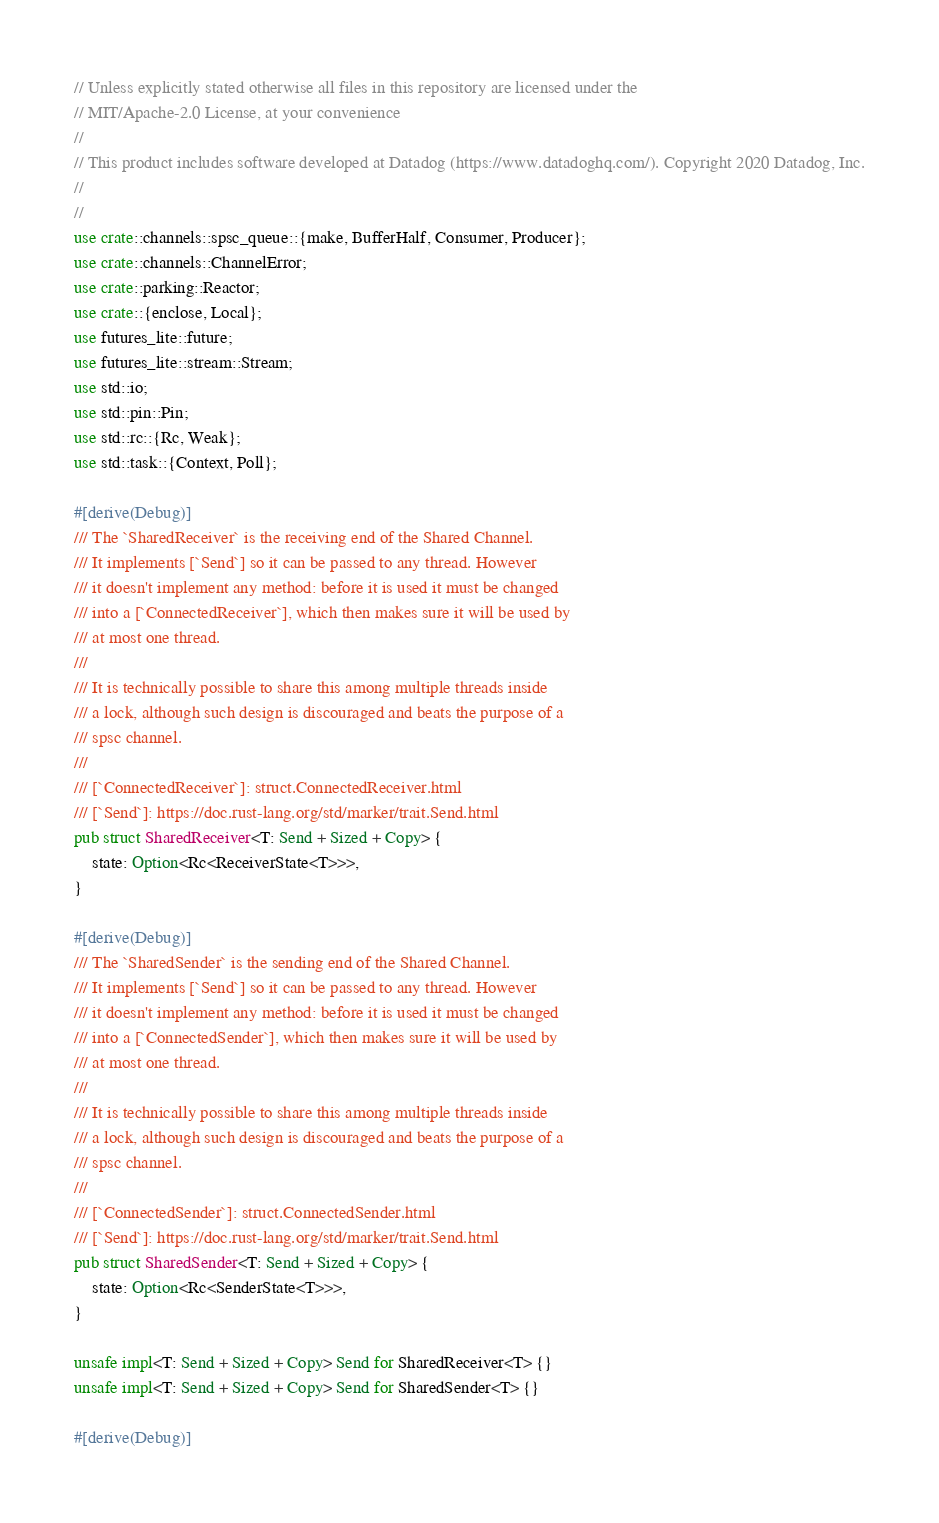<code> <loc_0><loc_0><loc_500><loc_500><_Rust_>// Unless explicitly stated otherwise all files in this repository are licensed under the
// MIT/Apache-2.0 License, at your convenience
//
// This product includes software developed at Datadog (https://www.datadoghq.com/). Copyright 2020 Datadog, Inc.
//
//
use crate::channels::spsc_queue::{make, BufferHalf, Consumer, Producer};
use crate::channels::ChannelError;
use crate::parking::Reactor;
use crate::{enclose, Local};
use futures_lite::future;
use futures_lite::stream::Stream;
use std::io;
use std::pin::Pin;
use std::rc::{Rc, Weak};
use std::task::{Context, Poll};

#[derive(Debug)]
/// The `SharedReceiver` is the receiving end of the Shared Channel.
/// It implements [`Send`] so it can be passed to any thread. However
/// it doesn't implement any method: before it is used it must be changed
/// into a [`ConnectedReceiver`], which then makes sure it will be used by
/// at most one thread.
///
/// It is technically possible to share this among multiple threads inside
/// a lock, although such design is discouraged and beats the purpose of a
/// spsc channel.
///
/// [`ConnectedReceiver`]: struct.ConnectedReceiver.html
/// [`Send`]: https://doc.rust-lang.org/std/marker/trait.Send.html
pub struct SharedReceiver<T: Send + Sized + Copy> {
    state: Option<Rc<ReceiverState<T>>>,
}

#[derive(Debug)]
/// The `SharedSender` is the sending end of the Shared Channel.
/// It implements [`Send`] so it can be passed to any thread. However
/// it doesn't implement any method: before it is used it must be changed
/// into a [`ConnectedSender`], which then makes sure it will be used by
/// at most one thread.
///
/// It is technically possible to share this among multiple threads inside
/// a lock, although such design is discouraged and beats the purpose of a
/// spsc channel.
///
/// [`ConnectedSender`]: struct.ConnectedSender.html
/// [`Send`]: https://doc.rust-lang.org/std/marker/trait.Send.html
pub struct SharedSender<T: Send + Sized + Copy> {
    state: Option<Rc<SenderState<T>>>,
}

unsafe impl<T: Send + Sized + Copy> Send for SharedReceiver<T> {}
unsafe impl<T: Send + Sized + Copy> Send for SharedSender<T> {}

#[derive(Debug)]</code> 